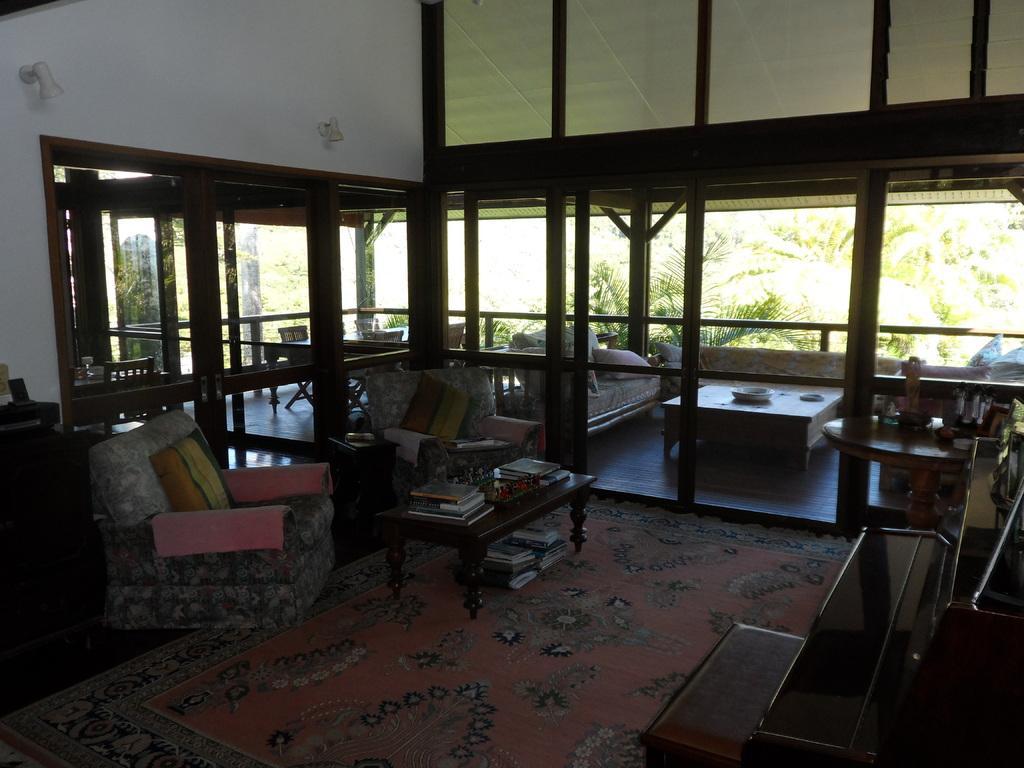Please provide a concise description of this image. In this image I can see chair,pillow. On the table there are books. There is a couch. 